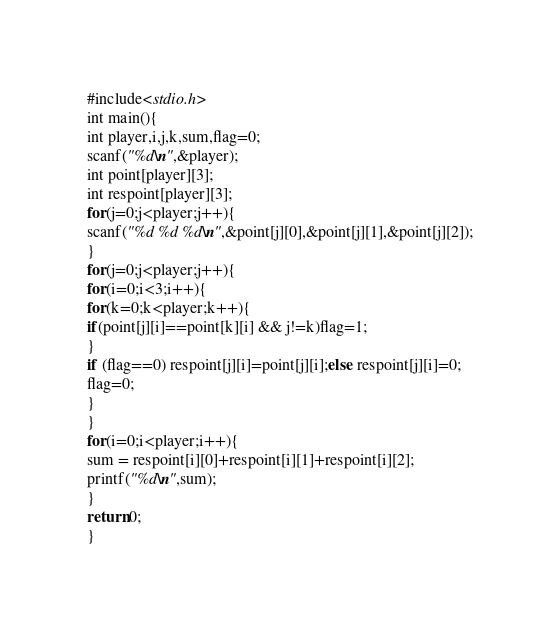Convert code to text. <code><loc_0><loc_0><loc_500><loc_500><_C_>#include<stdio.h>
int main(){
int player,i,j,k,sum,flag=0;
scanf("%d\n",&player);
int point[player][3];
int respoint[player][3];
for(j=0;j<player;j++){
scanf("%d %d %d\n",&point[j][0],&point[j][1],&point[j][2]);
}
for(j=0;j<player;j++){
for(i=0;i<3;i++){
for(k=0;k<player;k++){
if(point[j][i]==point[k][i] && j!=k)flag=1;
}
if (flag==0) respoint[j][i]=point[j][i];else respoint[j][i]=0;
flag=0;
}
}
for(i=0;i<player;i++){
sum = respoint[i][0]+respoint[i][1]+respoint[i][2];
printf("%d\n",sum);
}
return 0;
}</code> 